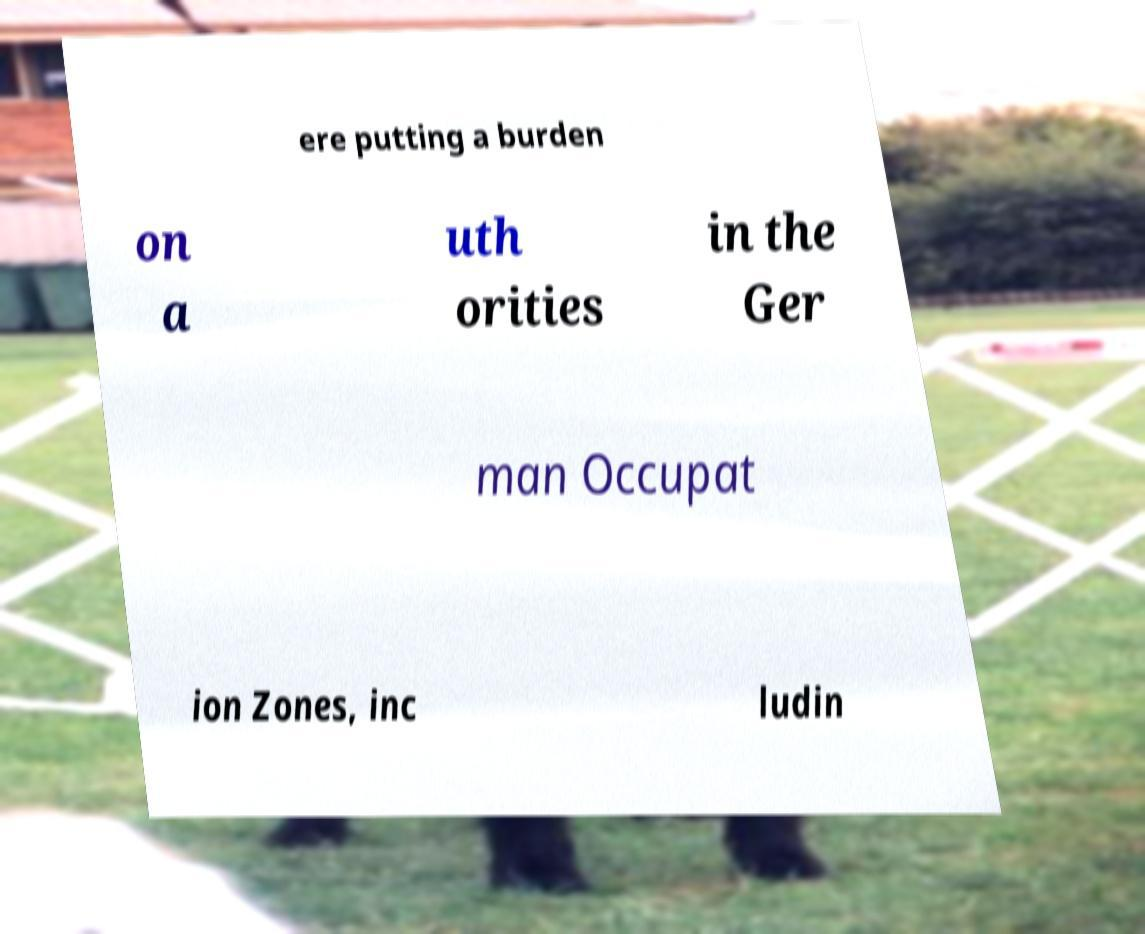Could you extract and type out the text from this image? ere putting a burden on a uth orities in the Ger man Occupat ion Zones, inc ludin 